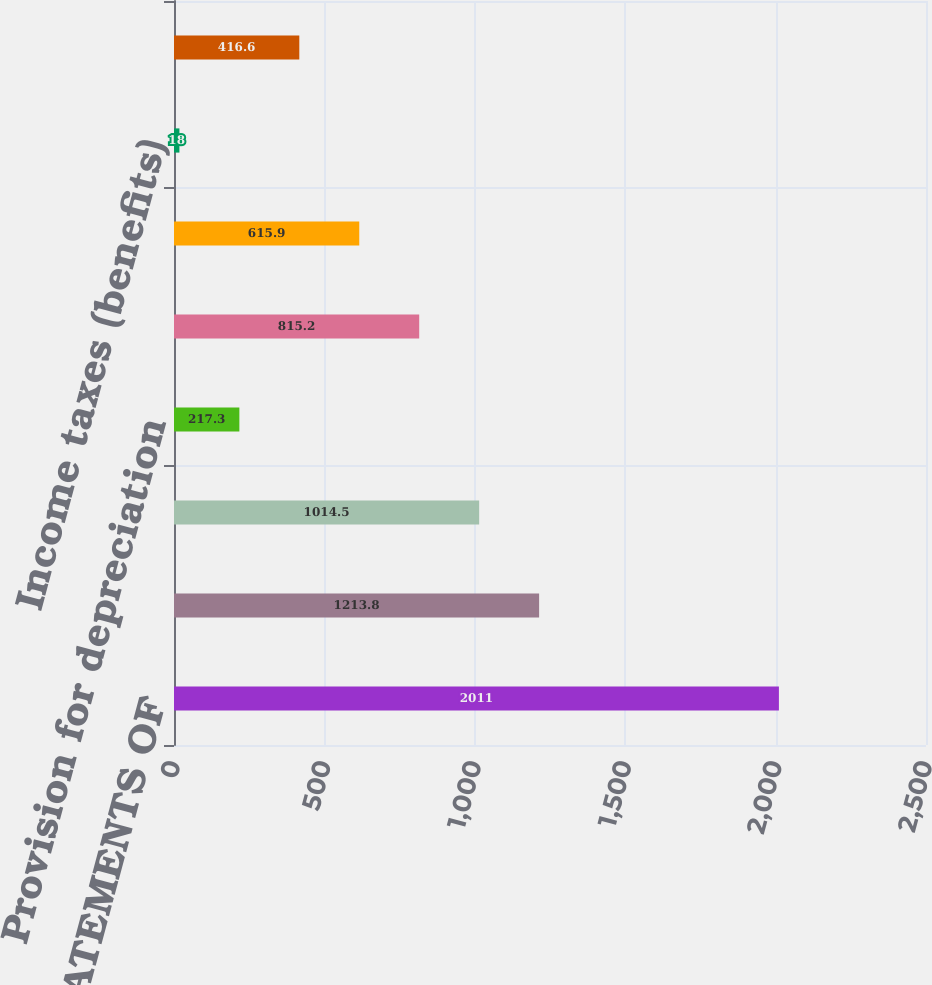<chart> <loc_0><loc_0><loc_500><loc_500><bar_chart><fcel>CONSOLIDATED STATEMENTS OF<fcel>Revenues<fcel>Other operating expense<fcel>Provision for depreciation<fcel>Operating Income (Loss)<fcel>Income (loss) before income<fcel>Income taxes (benefits)<fcel>Net Income (Loss)<nl><fcel>2011<fcel>1213.8<fcel>1014.5<fcel>217.3<fcel>815.2<fcel>615.9<fcel>18<fcel>416.6<nl></chart> 